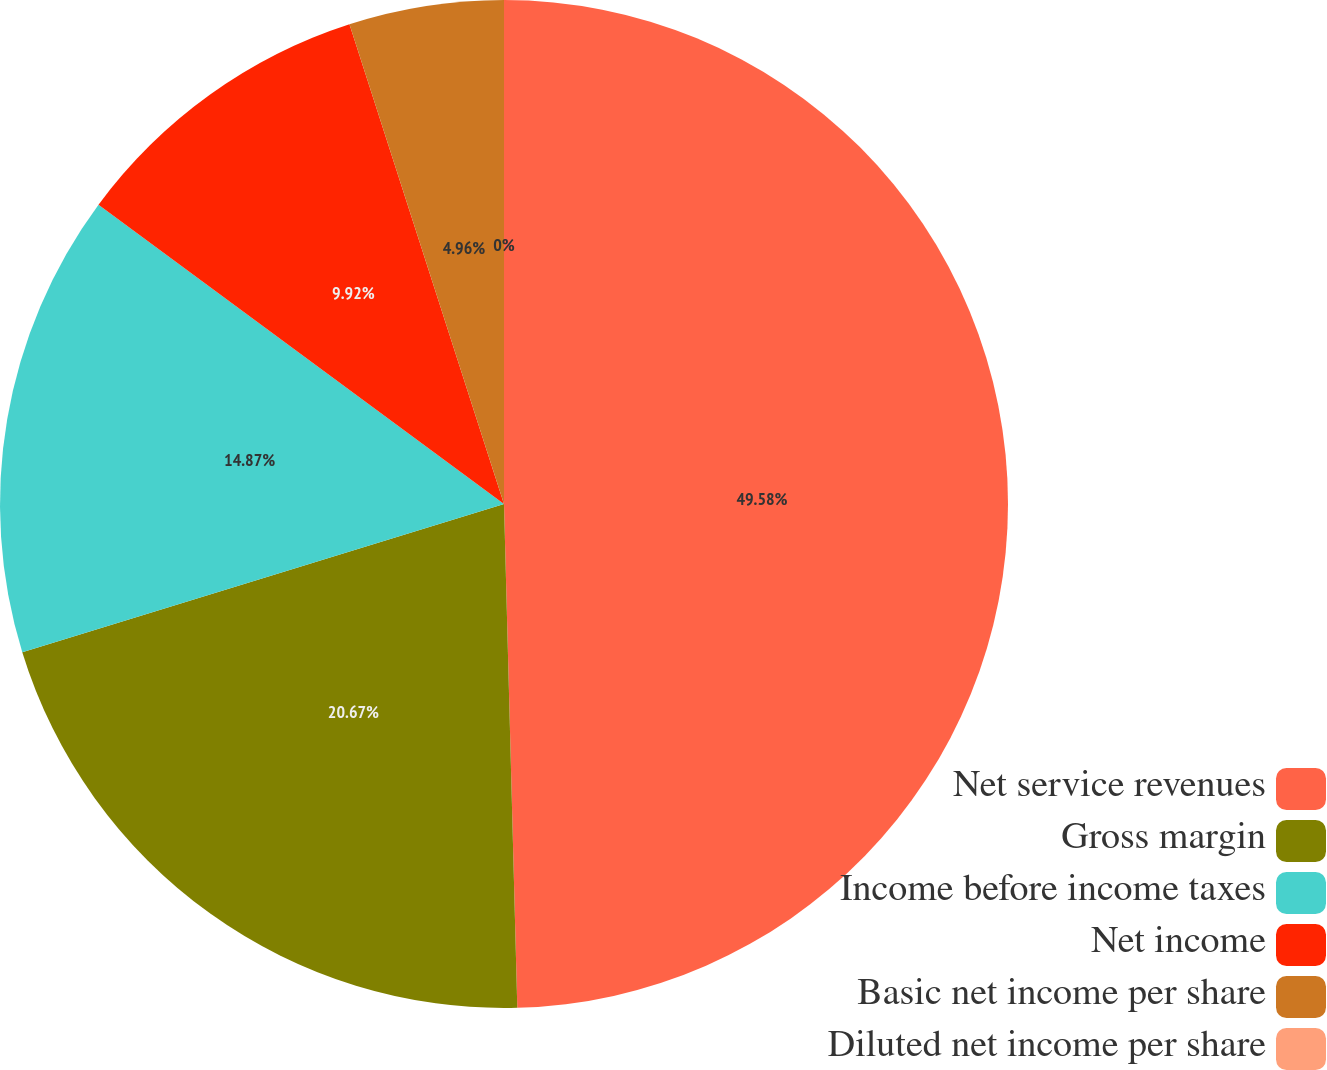<chart> <loc_0><loc_0><loc_500><loc_500><pie_chart><fcel>Net service revenues<fcel>Gross margin<fcel>Income before income taxes<fcel>Net income<fcel>Basic net income per share<fcel>Diluted net income per share<nl><fcel>49.58%<fcel>20.67%<fcel>14.87%<fcel>9.92%<fcel>4.96%<fcel>0.0%<nl></chart> 